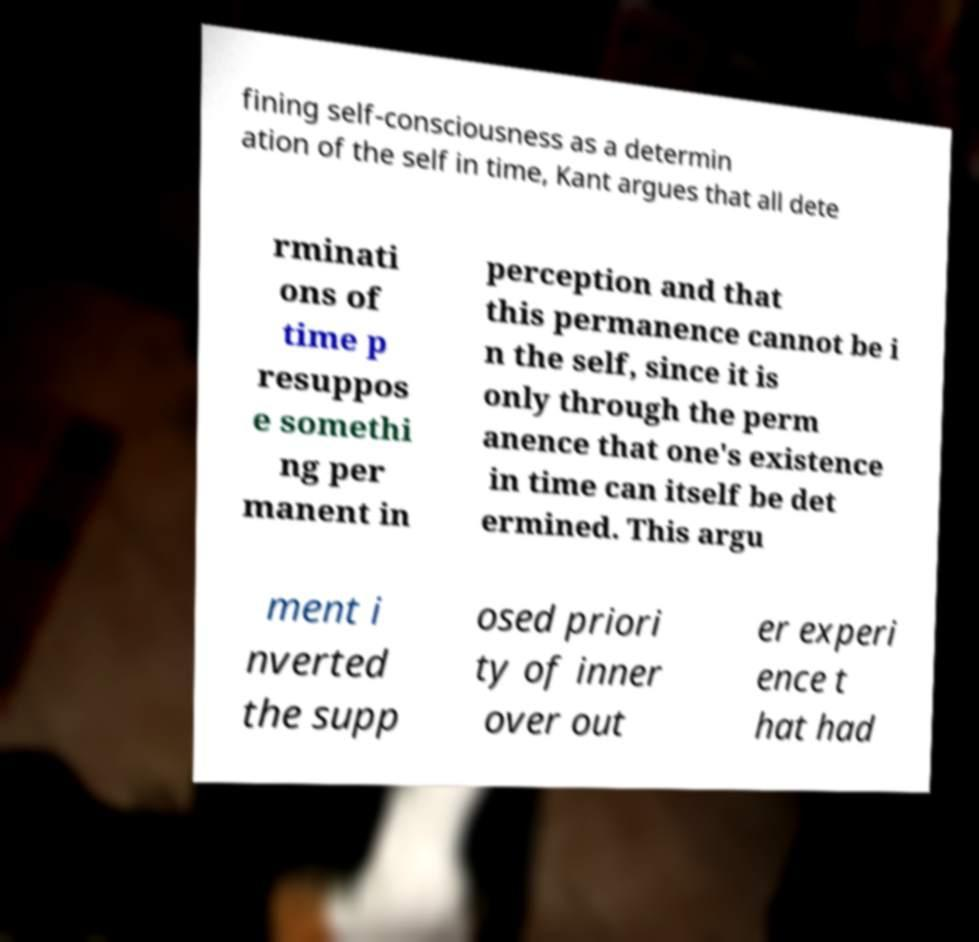I need the written content from this picture converted into text. Can you do that? fining self-consciousness as a determin ation of the self in time, Kant argues that all dete rminati ons of time p resuppos e somethi ng per manent in perception and that this permanence cannot be i n the self, since it is only through the perm anence that one's existence in time can itself be det ermined. This argu ment i nverted the supp osed priori ty of inner over out er experi ence t hat had 